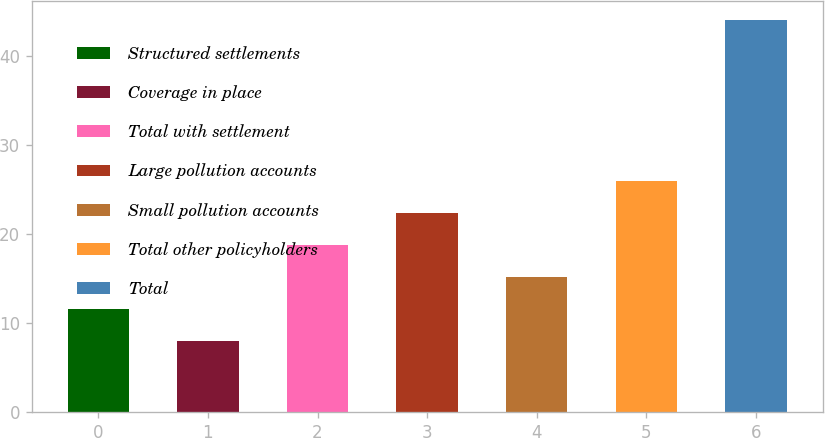<chart> <loc_0><loc_0><loc_500><loc_500><bar_chart><fcel>Structured settlements<fcel>Coverage in place<fcel>Total with settlement<fcel>Large pollution accounts<fcel>Small pollution accounts<fcel>Total other policyholders<fcel>Total<nl><fcel>11.6<fcel>8<fcel>18.8<fcel>22.4<fcel>15.2<fcel>26<fcel>44<nl></chart> 